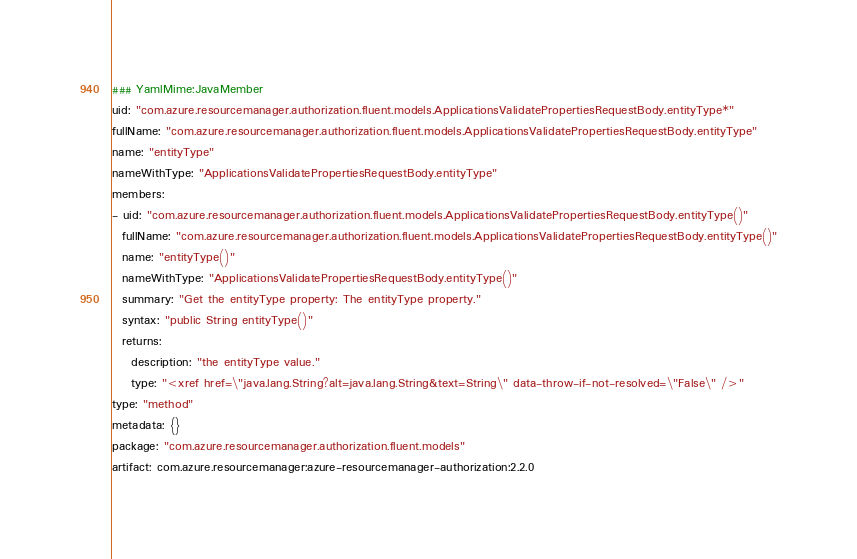<code> <loc_0><loc_0><loc_500><loc_500><_YAML_>### YamlMime:JavaMember
uid: "com.azure.resourcemanager.authorization.fluent.models.ApplicationsValidatePropertiesRequestBody.entityType*"
fullName: "com.azure.resourcemanager.authorization.fluent.models.ApplicationsValidatePropertiesRequestBody.entityType"
name: "entityType"
nameWithType: "ApplicationsValidatePropertiesRequestBody.entityType"
members:
- uid: "com.azure.resourcemanager.authorization.fluent.models.ApplicationsValidatePropertiesRequestBody.entityType()"
  fullName: "com.azure.resourcemanager.authorization.fluent.models.ApplicationsValidatePropertiesRequestBody.entityType()"
  name: "entityType()"
  nameWithType: "ApplicationsValidatePropertiesRequestBody.entityType()"
  summary: "Get the entityType property: The entityType property."
  syntax: "public String entityType()"
  returns:
    description: "the entityType value."
    type: "<xref href=\"java.lang.String?alt=java.lang.String&text=String\" data-throw-if-not-resolved=\"False\" />"
type: "method"
metadata: {}
package: "com.azure.resourcemanager.authorization.fluent.models"
artifact: com.azure.resourcemanager:azure-resourcemanager-authorization:2.2.0
</code> 